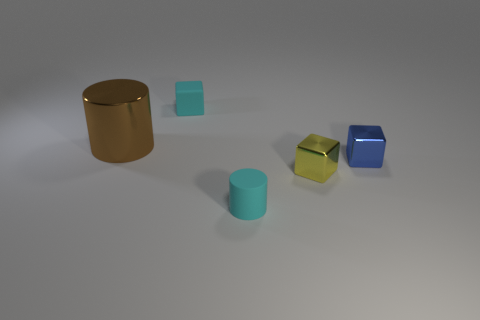Subtract all small blue cubes. How many cubes are left? 2 Subtract all cyan cylinders. How many cylinders are left? 1 Add 2 small rubber objects. How many objects exist? 7 Subtract 0 red cubes. How many objects are left? 5 Subtract all cylinders. How many objects are left? 3 Subtract all yellow blocks. Subtract all yellow cylinders. How many blocks are left? 2 Subtract all gray spheres. How many cyan cylinders are left? 1 Subtract all cylinders. Subtract all large yellow cylinders. How many objects are left? 3 Add 5 tiny things. How many tiny things are left? 9 Add 5 tiny blue shiny objects. How many tiny blue shiny objects exist? 6 